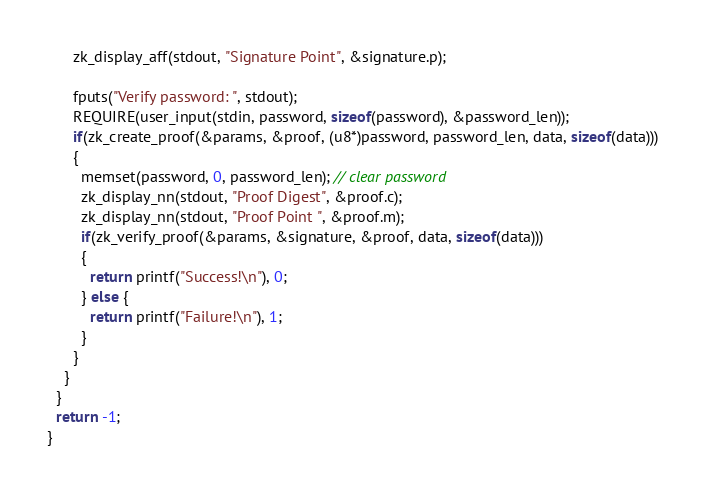Convert code to text. <code><loc_0><loc_0><loc_500><loc_500><_C_>      zk_display_aff(stdout, "Signature Point", &signature.p);

      fputs("Verify password: ", stdout);
      REQUIRE(user_input(stdin, password, sizeof(password), &password_len));
      if(zk_create_proof(&params, &proof, (u8*)password, password_len, data, sizeof(data)))
      {
        memset(password, 0, password_len); // clear password
        zk_display_nn(stdout, "Proof Digest", &proof.c);
        zk_display_nn(stdout, "Proof Point ", &proof.m);
        if(zk_verify_proof(&params, &signature, &proof, data, sizeof(data)))
        {
          return printf("Success!\n"), 0;
        } else {
          return printf("Failure!\n"), 1;
        }
      }
    }
  }
  return -1;
}
</code> 